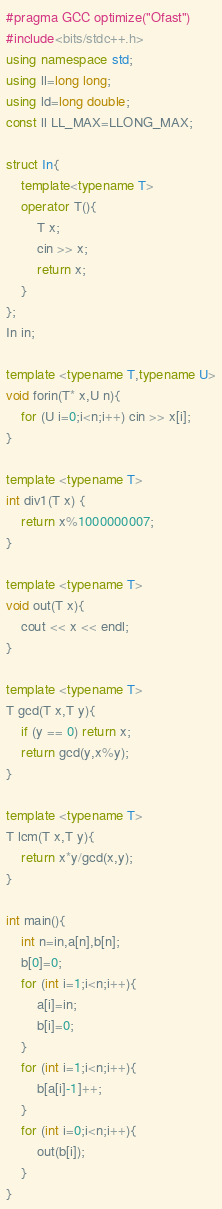Convert code to text. <code><loc_0><loc_0><loc_500><loc_500><_C++_>#pragma GCC optimize("Ofast")
#include<bits/stdc++.h>
using namespace std;
using ll=long long;
using ld=long double;
const ll LL_MAX=LLONG_MAX;

struct In{
    template<typename T>
    operator T(){
        T x;
        cin >> x;
        return x;
    }
};
In in;

template <typename T,typename U>
void forin(T* x,U n){
    for (U i=0;i<n;i++) cin >> x[i];
}

template <typename T>
int div1(T x) {
    return x%1000000007;
}

template <typename T>
void out(T x){
    cout << x << endl;
}

template <typename T>
T gcd(T x,T y){
    if (y == 0) return x;
    return gcd(y,x%y);
}

template <typename T>
T lcm(T x,T y){
    return x*y/gcd(x,y);
}

int main(){
    int n=in,a[n],b[n];
    b[0]=0;
    for (int i=1;i<n;i++){
        a[i]=in;
        b[i]=0;
    }
    for (int i=1;i<n;i++){
        b[a[i]-1]++;
    }
    for (int i=0;i<n;i++){
        out(b[i]);
    }
}</code> 